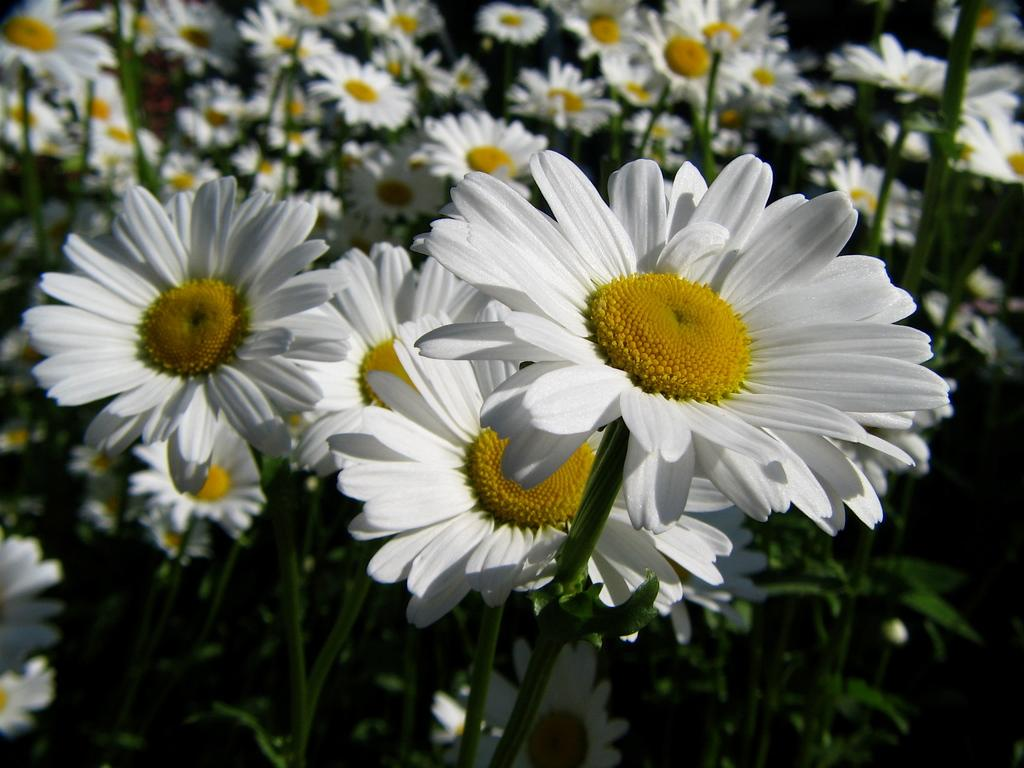What type of plant life is visible in the image? There are flowers, stems, and leaves in the image. Can you describe the different parts of the plants in the image? Yes, the image shows flowers, stems, and leaves. What type of zebra can be seen playing with a kitty in the image? There is no zebra or kitty present in the image; it features flowers, stems, and leaves. How many points does the flower have in the image? The provided facts do not mention the number of points on the flowers, so it cannot be determined from the image. 